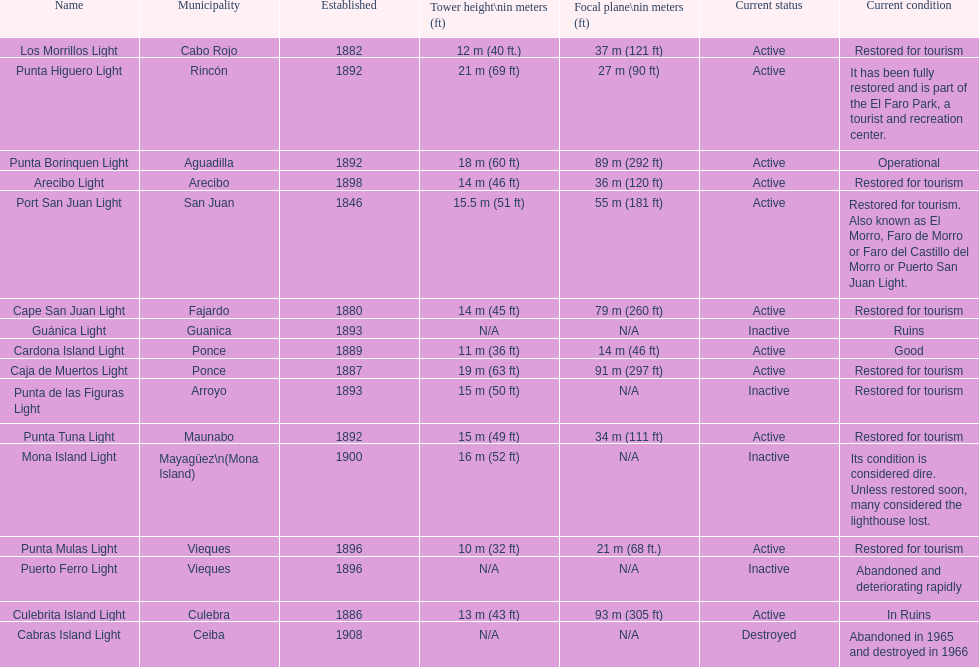How many towers have a height of 18 meters or more? 3. 